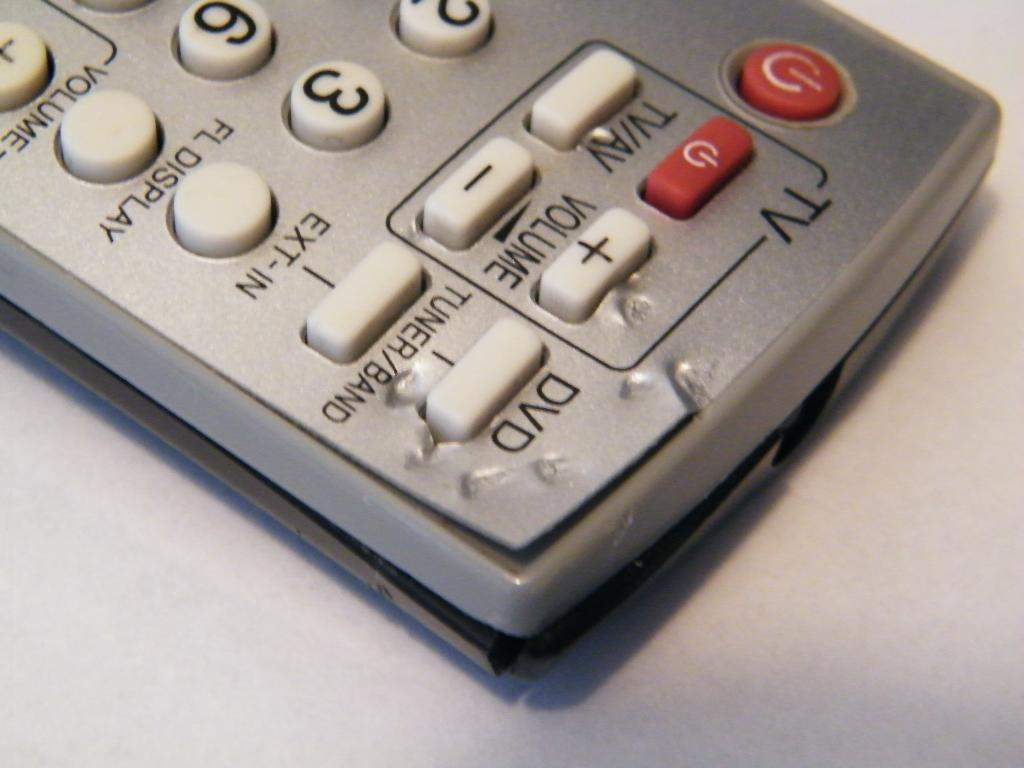What object is the main focus of the image? The main focus of the image is a TV remote. What functions can be controlled using the TV remote? The TV remote has buttons for power, volume, DVD, and some number buttons. What type of canvas is being used to paint a picture of a donkey in the image? There is no canvas or donkey present in the image; it only features a TV remote. 